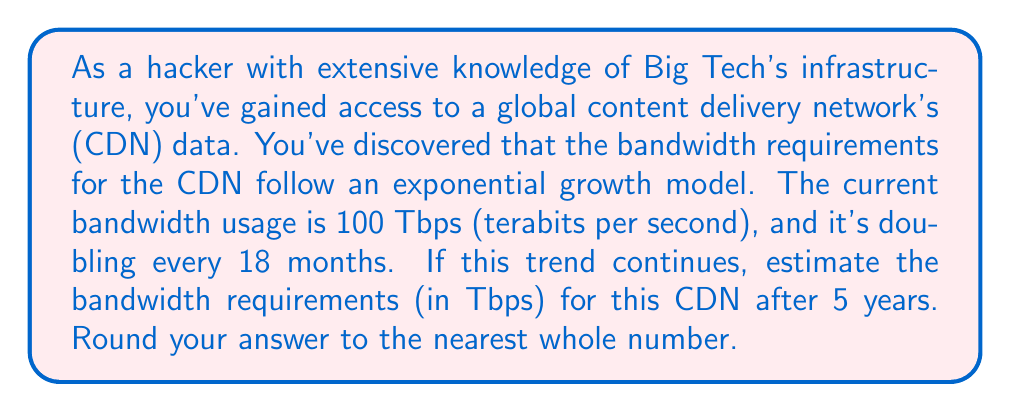Show me your answer to this math problem. To solve this problem, we need to use an exponential function model. Let's break it down step-by-step:

1) The general form of an exponential function is:
   $$ A(t) = A_0 \cdot b^t $$
   where $A(t)$ is the amount at time $t$, $A_0$ is the initial amount, $b$ is the growth factor, and $t$ is the time.

2) We know:
   - Initial bandwidth: $A_0 = 100$ Tbps
   - Doubling time: 18 months
   - Time period: 5 years = 60 months

3) To find the growth factor $b$, we use the doubling time:
   $$ 2 = b^{18} $$
   $$ b = 2^{\frac{1}{18}} \approx 1.0393 $$

4) Now, we need to calculate how many 18-month periods are in 5 years:
   $$ \text{Number of periods} = \frac{60 \text{ months}}{18 \text{ months/period}} = \frac{10}{3} \text{ periods} $$

5) We can now use our exponential function:
   $$ A(5\text{ years}) = 100 \cdot (2^{\frac{1}{18}})^{\frac{10}{3}} $$

6) Simplifying:
   $$ A(5\text{ years}) = 100 \cdot 2^{\frac{10}{54}} \approx 100 \cdot 1.1378 $$

7) Calculating:
   $$ A(5\text{ years}) \approx 800.7 \text{ Tbps} $$

8) Rounding to the nearest whole number:
   $$ A(5\text{ years}) \approx 801 \text{ Tbps} $$
Answer: 801 Tbps 